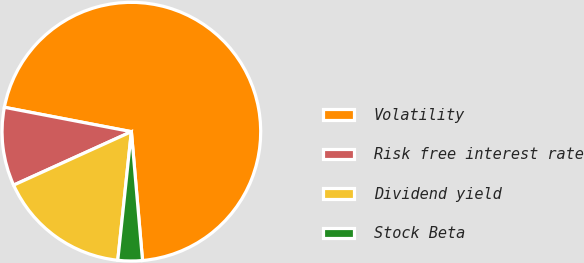Convert chart. <chart><loc_0><loc_0><loc_500><loc_500><pie_chart><fcel>Volatility<fcel>Risk free interest rate<fcel>Dividend yield<fcel>Stock Beta<nl><fcel>70.61%<fcel>9.8%<fcel>16.54%<fcel>3.05%<nl></chart> 